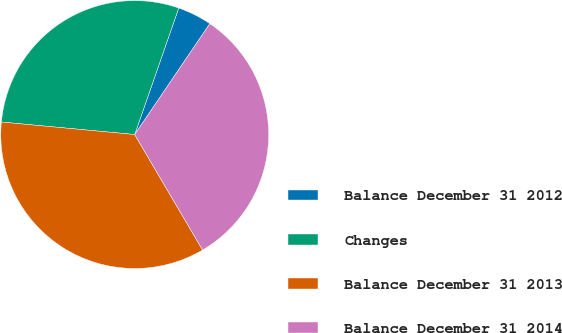Convert chart to OTSL. <chart><loc_0><loc_0><loc_500><loc_500><pie_chart><fcel>Balance December 31 2012<fcel>Changes<fcel>Balance December 31 2013<fcel>Balance December 31 2014<nl><fcel>4.15%<fcel>28.84%<fcel>34.95%<fcel>32.06%<nl></chart> 